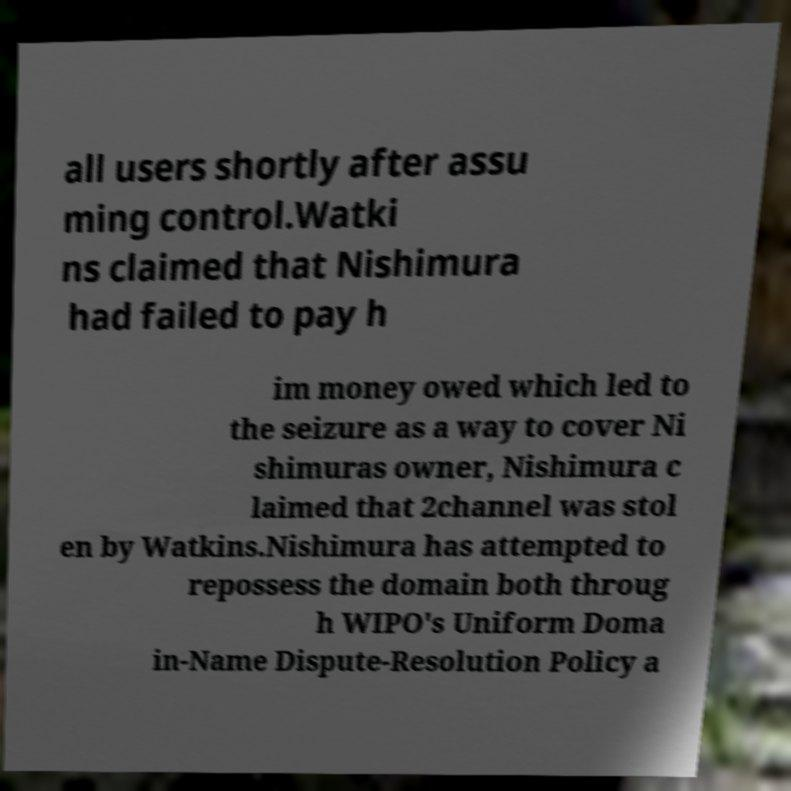There's text embedded in this image that I need extracted. Can you transcribe it verbatim? all users shortly after assu ming control.Watki ns claimed that Nishimura had failed to pay h im money owed which led to the seizure as a way to cover Ni shimuras owner, Nishimura c laimed that 2channel was stol en by Watkins.Nishimura has attempted to repossess the domain both throug h WIPO's Uniform Doma in-Name Dispute-Resolution Policy a 